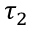<formula> <loc_0><loc_0><loc_500><loc_500>\tau _ { 2 }</formula> 